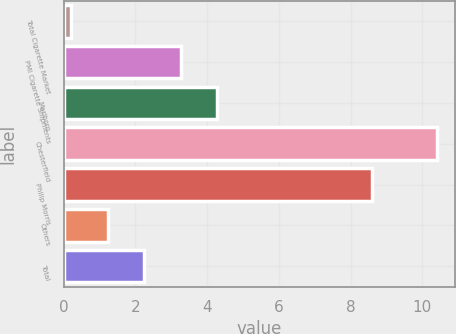Convert chart to OTSL. <chart><loc_0><loc_0><loc_500><loc_500><bar_chart><fcel>Total Cigarette Market<fcel>PMI Cigarette Shipments<fcel>Marlboro<fcel>Chesterfield<fcel>Philip Morris<fcel>Others<fcel>Total<nl><fcel>0.2<fcel>3.26<fcel>4.28<fcel>10.4<fcel>8.6<fcel>1.22<fcel>2.24<nl></chart> 